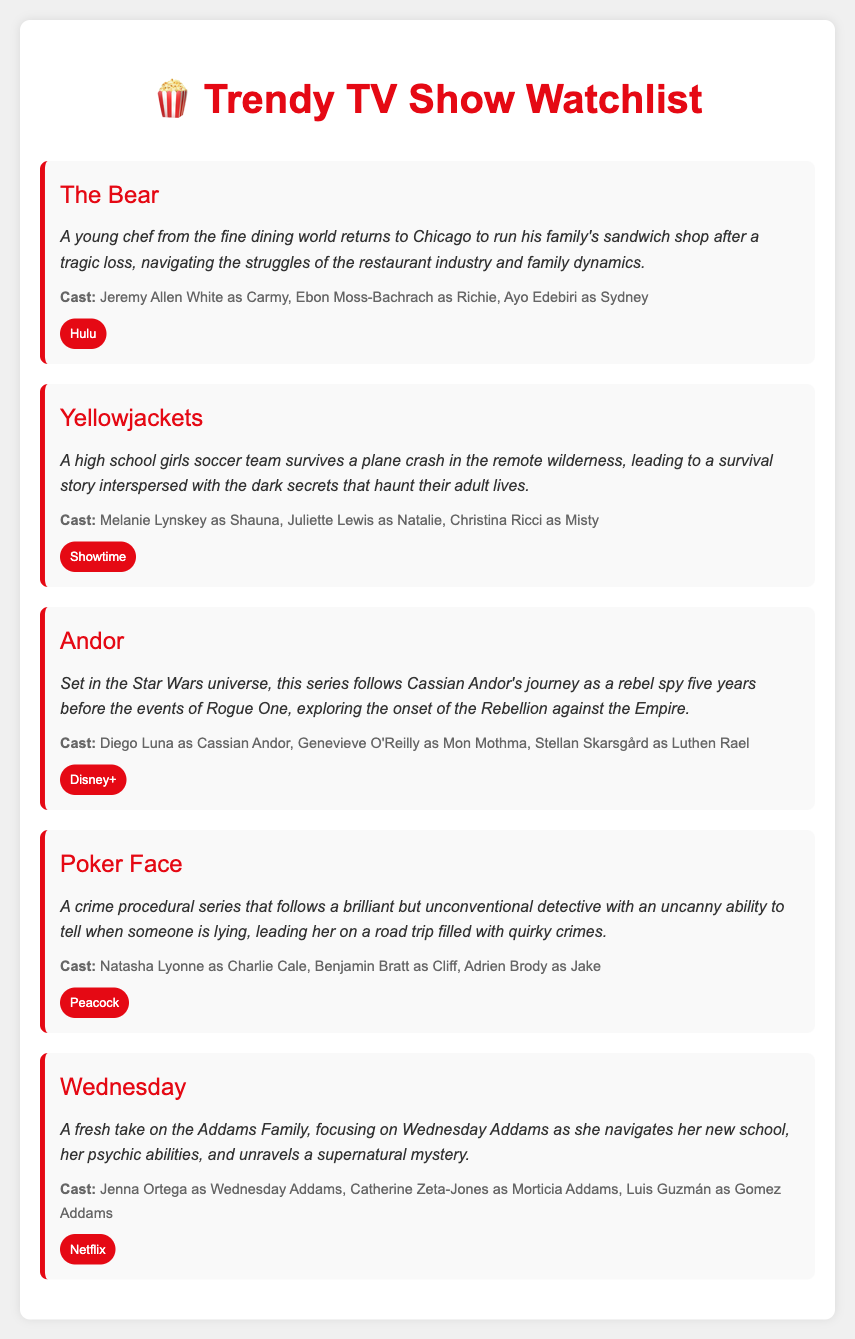What is the title of the first show? The first show listed in the document is "The Bear."
Answer: The Bear Who stars as Wednesday Addams? Jenna Ortega plays the role of Wednesday Addams in the show "Wednesday."
Answer: Jenna Ortega Which streaming platform features "Andor"? The show "Andor" is available on Disney+.
Answer: Disney+ What genre does "Poker Face" belong to? "Poker Face" is described as a crime procedural series.
Answer: Crime procedural How many main cast members are listed for "Yellowjackets"? The show "Yellowjackets" lists three main cast members.
Answer: Three What is the central theme of "The Bear"? "The Bear" revolves around a young chef running a family sandwich shop amid personal struggles.
Answer: Family dynamics Which show involves a plane crash survival story? The show "Yellowjackets" features a survival story following a plane crash.
Answer: Yellowjackets What color is the show card border for "Wednesday"? The border color of the show card for "Wednesday" is red.
Answer: Red 